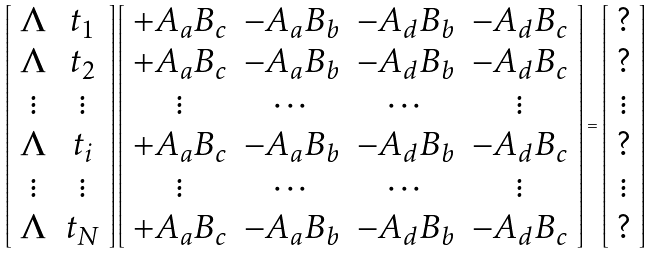<formula> <loc_0><loc_0><loc_500><loc_500>\left [ \begin{array} { c c } { \Lambda } & { t _ { 1 } } \\ { \Lambda } & { t _ { 2 } } \\ \vdots & \vdots \\ { \Lambda } & { t _ { i } } \\ \vdots & \vdots \\ { \Lambda } & { t _ { N } } \end{array} \right ] \left [ \begin{array} { c c c c } + { A _ { a } } { B _ { c } } & - { A _ { a } } { B _ { b } } & - { A _ { d } } { B _ { b } } & - { A _ { d } } { B _ { c } } \\ + { A _ { a } } { B _ { c } } & - { A _ { a } } { B _ { b } } & - { A _ { d } } { B _ { b } } & - { A _ { d } } { B _ { c } } \\ \vdots & \cdots & \cdots & \vdots \\ + { A _ { a } } { B _ { c } } & - { A _ { a } } { B _ { b } } & - { A _ { d } } { B _ { b } } & - { A _ { d } } { B _ { c } } \\ \vdots & \cdots & \cdots & \vdots \\ + { A _ { a } } { B _ { c } } & - { A _ { a } } { B _ { b } } & - { A _ { d } } { B _ { b } } & - { A _ { d } } { B _ { c } } \end{array} \right ] = \left [ \begin{array} { c } ? \\ ? \\ \vdots \\ ? \\ \vdots \\ ? \end{array} \right ]</formula> 